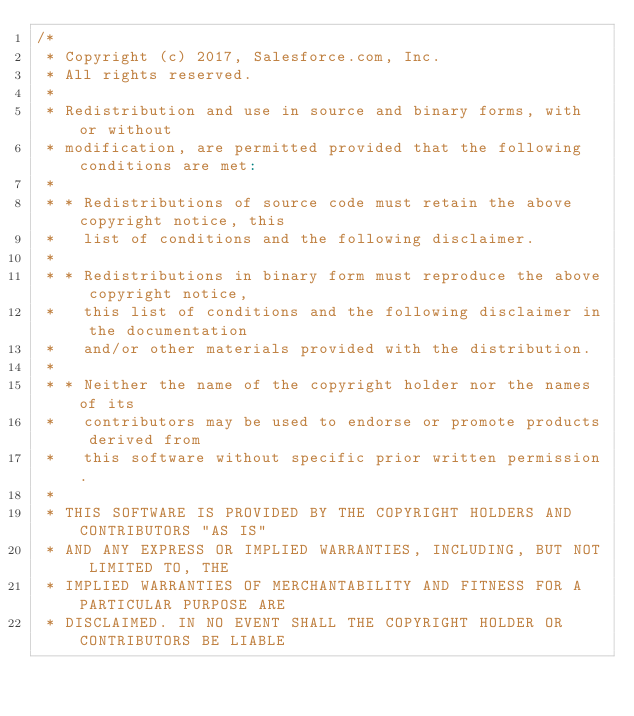Convert code to text. <code><loc_0><loc_0><loc_500><loc_500><_Scala_>/*
 * Copyright (c) 2017, Salesforce.com, Inc.
 * All rights reserved.
 *
 * Redistribution and use in source and binary forms, with or without
 * modification, are permitted provided that the following conditions are met:
 *
 * * Redistributions of source code must retain the above copyright notice, this
 *   list of conditions and the following disclaimer.
 *
 * * Redistributions in binary form must reproduce the above copyright notice,
 *   this list of conditions and the following disclaimer in the documentation
 *   and/or other materials provided with the distribution.
 *
 * * Neither the name of the copyright holder nor the names of its
 *   contributors may be used to endorse or promote products derived from
 *   this software without specific prior written permission.
 *
 * THIS SOFTWARE IS PROVIDED BY THE COPYRIGHT HOLDERS AND CONTRIBUTORS "AS IS"
 * AND ANY EXPRESS OR IMPLIED WARRANTIES, INCLUDING, BUT NOT LIMITED TO, THE
 * IMPLIED WARRANTIES OF MERCHANTABILITY AND FITNESS FOR A PARTICULAR PURPOSE ARE
 * DISCLAIMED. IN NO EVENT SHALL THE COPYRIGHT HOLDER OR CONTRIBUTORS BE LIABLE</code> 